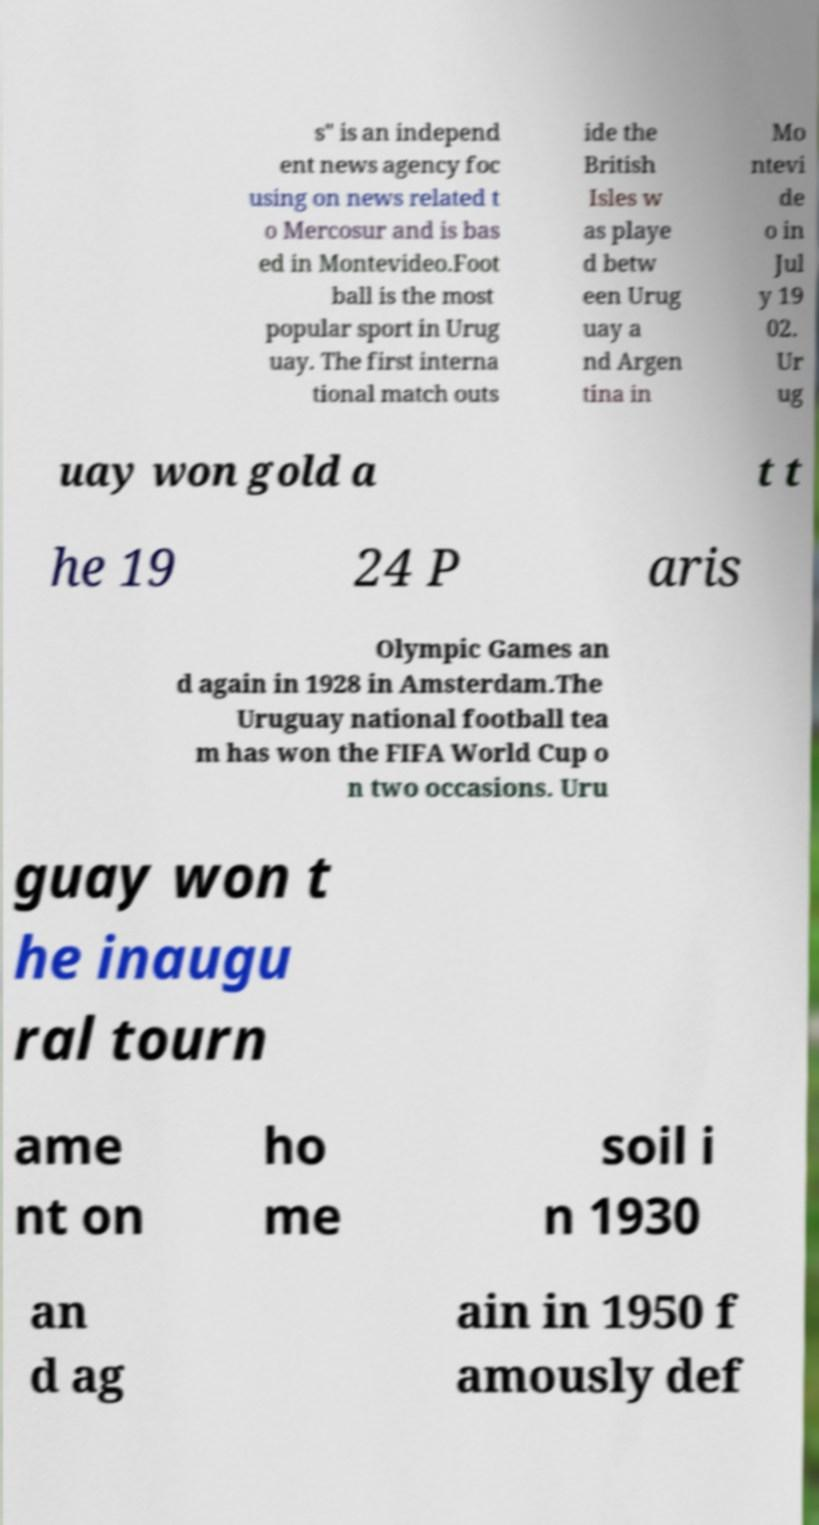Please identify and transcribe the text found in this image. s" is an independ ent news agency foc using on news related t o Mercosur and is bas ed in Montevideo.Foot ball is the most popular sport in Urug uay. The first interna tional match outs ide the British Isles w as playe d betw een Urug uay a nd Argen tina in Mo ntevi de o in Jul y 19 02. Ur ug uay won gold a t t he 19 24 P aris Olympic Games an d again in 1928 in Amsterdam.The Uruguay national football tea m has won the FIFA World Cup o n two occasions. Uru guay won t he inaugu ral tourn ame nt on ho me soil i n 1930 an d ag ain in 1950 f amously def 